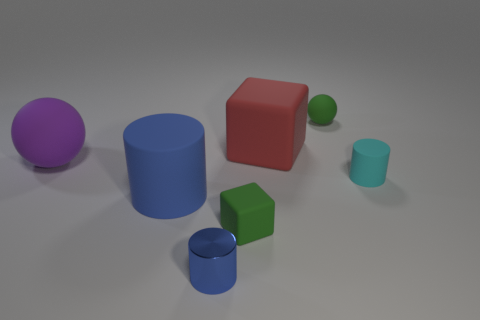What number of other objects are the same size as the cyan object? There are three objects that appear to be the same size as the cyan cube: the green cube, the smaller blue cylinder, and the purple sphere. It's worth noting that judging object size can sometimes be tricky if perspective or distance in the image is not considered, but based on this view, these objects seem to match in size. 